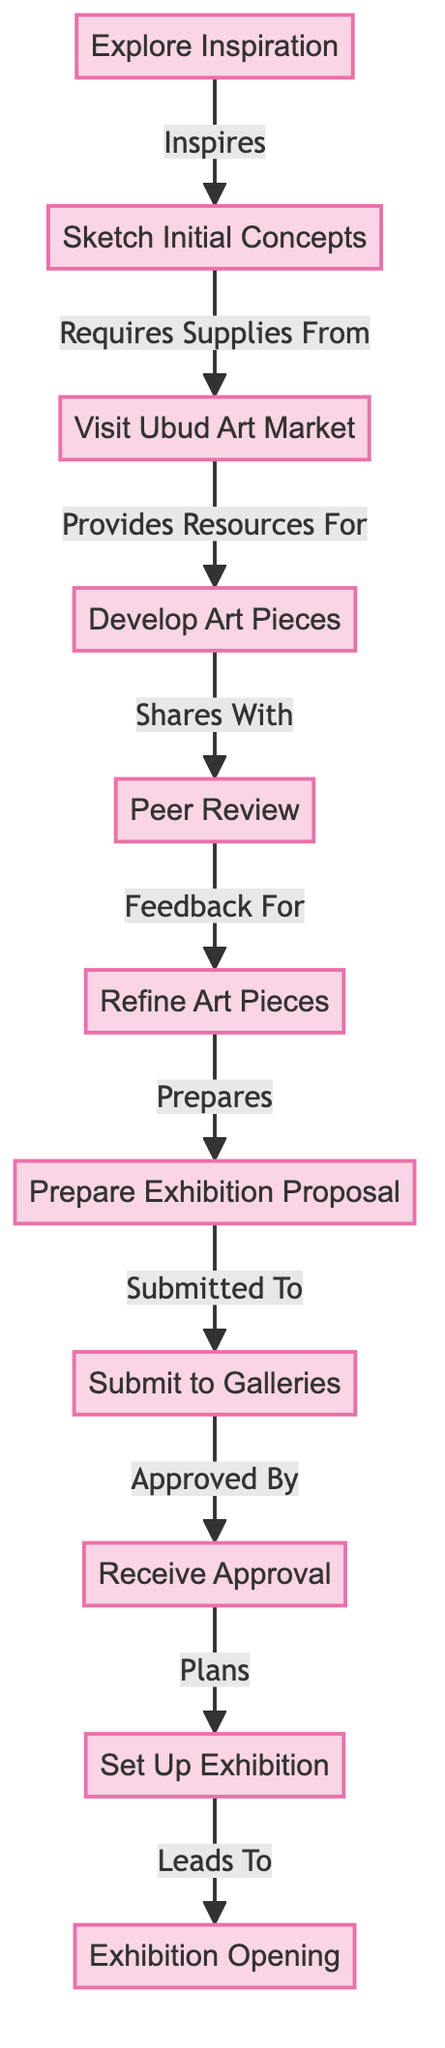What is the first step of the artist's journey? The diagram indicates that the first step is "Explore Inspiration". This node is connected to all subsequent actions as the initial phase of the artist's journey.
Answer: Explore Inspiration How many nodes are in the diagram? The diagram lists a total of 11 distinct nodes representing various stages in the artist's journey from inspiration to exhibition.
Answer: 11 What relationship exists between "Sketch Initial Concepts" and "Visit Ubud Art Market"? According to the diagram, "Sketch Initial Concepts" requires supplies from "Visit Ubud Art Market". This directed edge highlights the dependency of creating concepts on obtaining necessary materials.
Answer: Requires Supplies From What is the last step before the exhibition opening? The final step before the exhibition opening is "Set Up Exhibition". The diagram shows that this node leads directly to the final stage, ensuring the artwork is displayed correctly.
Answer: Set Up Exhibition Which node receives feedback from the peer review process? The "Refine Art Pieces" node receives feedback from the peer review process, indicating that changes based on critiques are necessary before proceeding further.
Answer: Refine Art Pieces How many edges are documented in this graph? The diagram illustrates 10 edges that connect the various nodes, indicating the relationships and flow between different stages of the artist's journey.
Answer: 10 Which stage requires incorporating feedback? The stage that requires incorporating feedback is "Refine Art Pieces". This node is specifically designed to take insights from the peer review and improve the artworks.
Answer: Refine Art Pieces What does the "Prepare Exhibition Proposal" node connect to? The "Prepare Exhibition Proposal" node connects to "Submit to Galleries", indicating that once the proposal is prepared, the next step is to submit it for consideration by galleries.
Answer: Submit to Galleries Which step leads to the exhibition opening? "Set Up Exhibition" is the step that leads directly to the exhibition opening, indicating that after setting up the artworks, the opening ceremony follows.
Answer: Leads To 